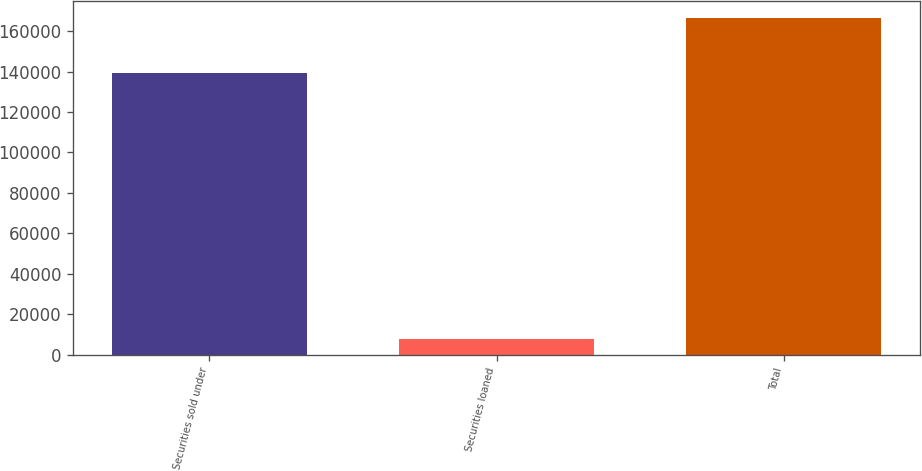Convert chart to OTSL. <chart><loc_0><loc_0><loc_500><loc_500><bar_chart><fcel>Securities sold under<fcel>Securities loaned<fcel>Total<nl><fcel>139017<fcel>7753<fcel>166676<nl></chart> 